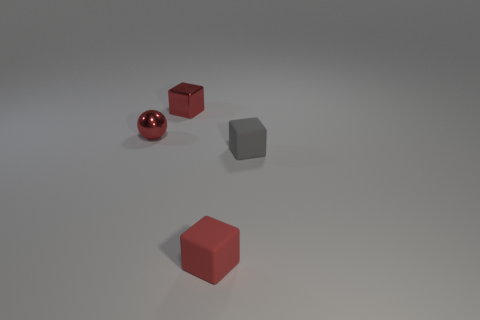There is a metallic block that is the same size as the red rubber object; what is its color?
Your answer should be compact. Red. What number of red objects are either metallic blocks or shiny balls?
Keep it short and to the point. 2. Is the number of big brown spheres greater than the number of small gray rubber objects?
Provide a short and direct response. No. Does the metallic thing that is behind the sphere have the same size as the red thing that is in front of the red metallic sphere?
Offer a terse response. Yes. What color is the tiny cube that is behind the red object on the left side of the metal object on the right side of the ball?
Provide a short and direct response. Red. Are there any other tiny things that have the same shape as the small gray thing?
Give a very brief answer. Yes. Is the number of rubber cubes that are in front of the ball greater than the number of tiny red metal balls?
Your response must be concise. Yes. What number of shiny objects are small red things or brown blocks?
Offer a terse response. 2. There is a red object that is both right of the red metal sphere and behind the small gray cube; how big is it?
Give a very brief answer. Small. Are there any balls that are on the left side of the shiny thing that is on the right side of the tiny red sphere?
Provide a short and direct response. Yes. 